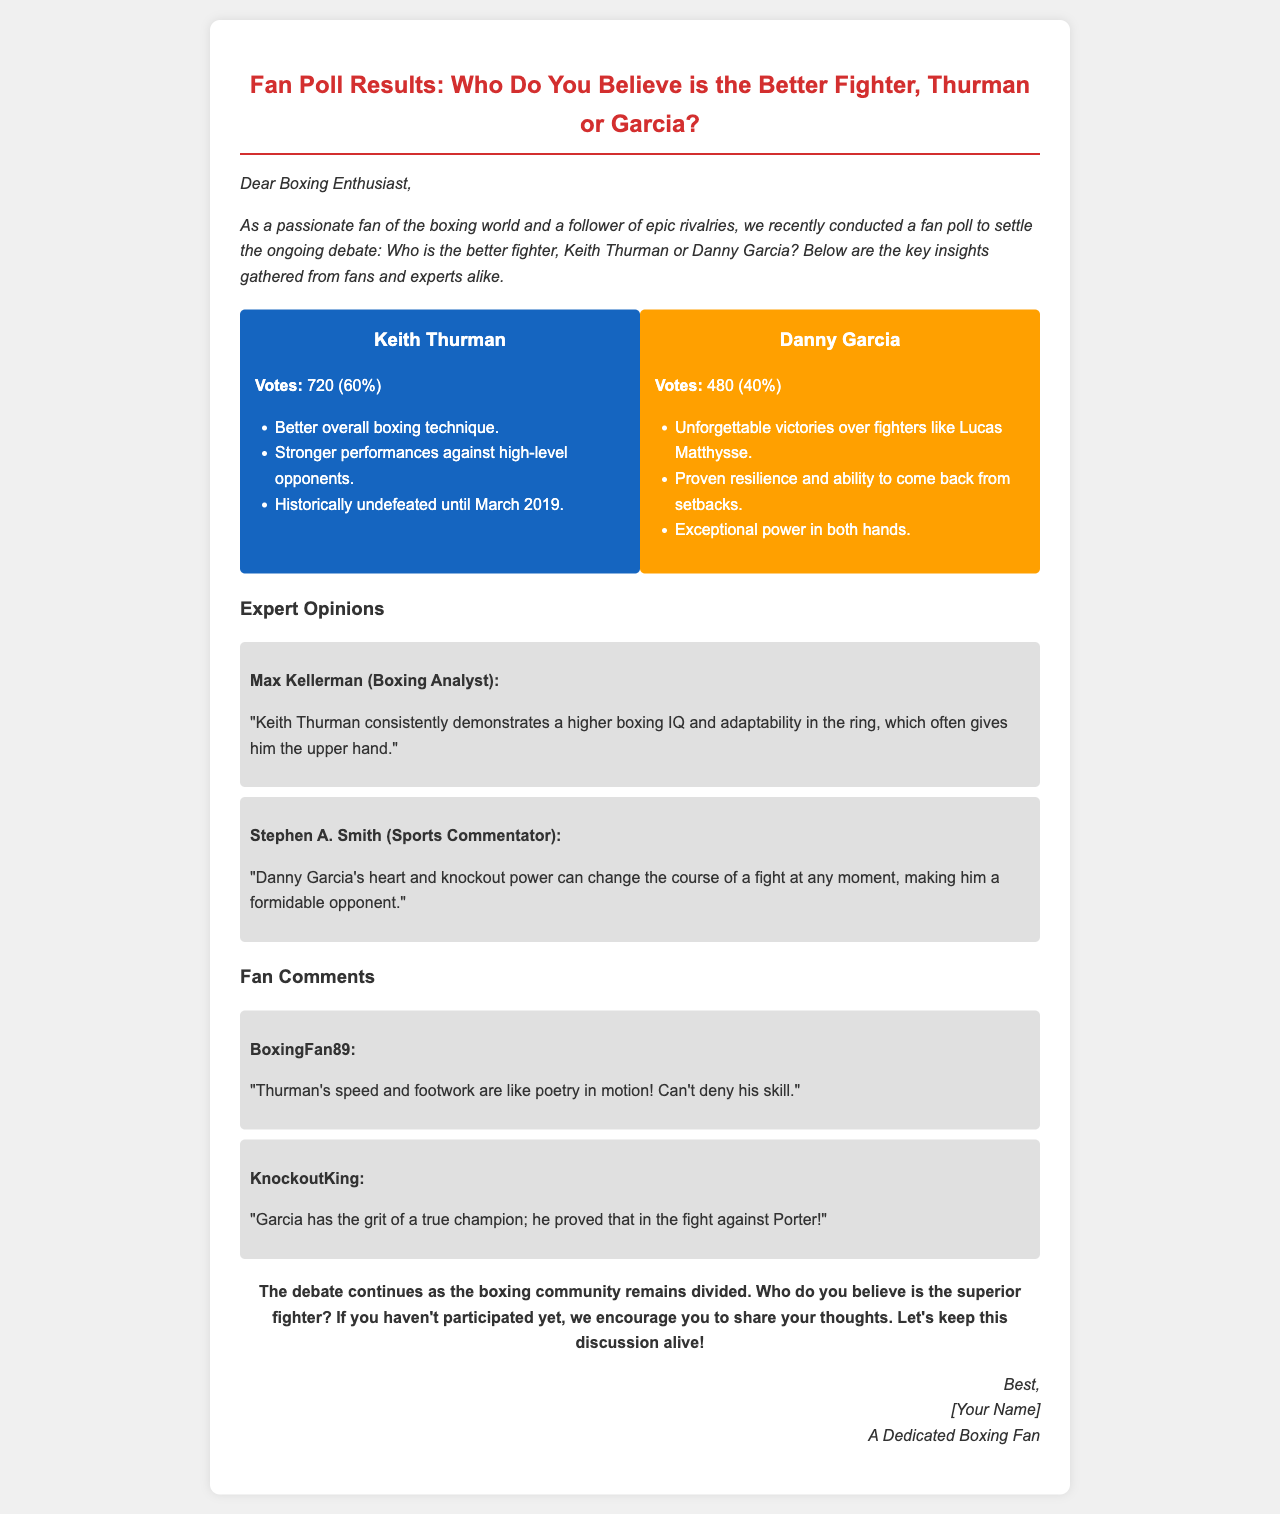What percentage of votes did Keith Thurman receive? The document states that Keith Thurman received 720 votes, which is 60%.
Answer: 60% What is one attribute that fans appreciate about Danny Garcia? The document lists "Exceptional power in both hands" as one of Danny Garcia's attributes.
Answer: Exceptional power in both hands Who is the boxing analyst mentioned in the expert opinions? Max Kellerman is identified as the boxing analyst in the expert opinions section.
Answer: Max Kellerman How many total votes were cast in the poll? There were 720 votes for Thurman and 480 votes for Garcia, which totals 1200 votes.
Answer: 1200 What is a notable achievement of Keith Thurman according to the poll results? The document states that he was "Historically undefeated until March 2019."
Answer: Historically undefeated until March 2019 Which fighter's resilience is highlighted in the document? The document mentions Danny Garcia's "Proven resilience and ability to come back from setbacks."
Answer: Danny Garcia What comment was made by Stephen A. Smith? Stephen A. Smith stated that "Danny Garcia's heart and knockout power can change the course of a fight at any moment."
Answer: Danny Garcia's heart and knockout power can change the course of a fight at any moment What is encouraged at the end of the document? The document encourages readers to share their thoughts and keep the discussion alive.
Answer: Share your thoughts Who is the audience of this email? The audience is identified as "Boxing Enthusiast" in the introduction.
Answer: Boxing Enthusiast 